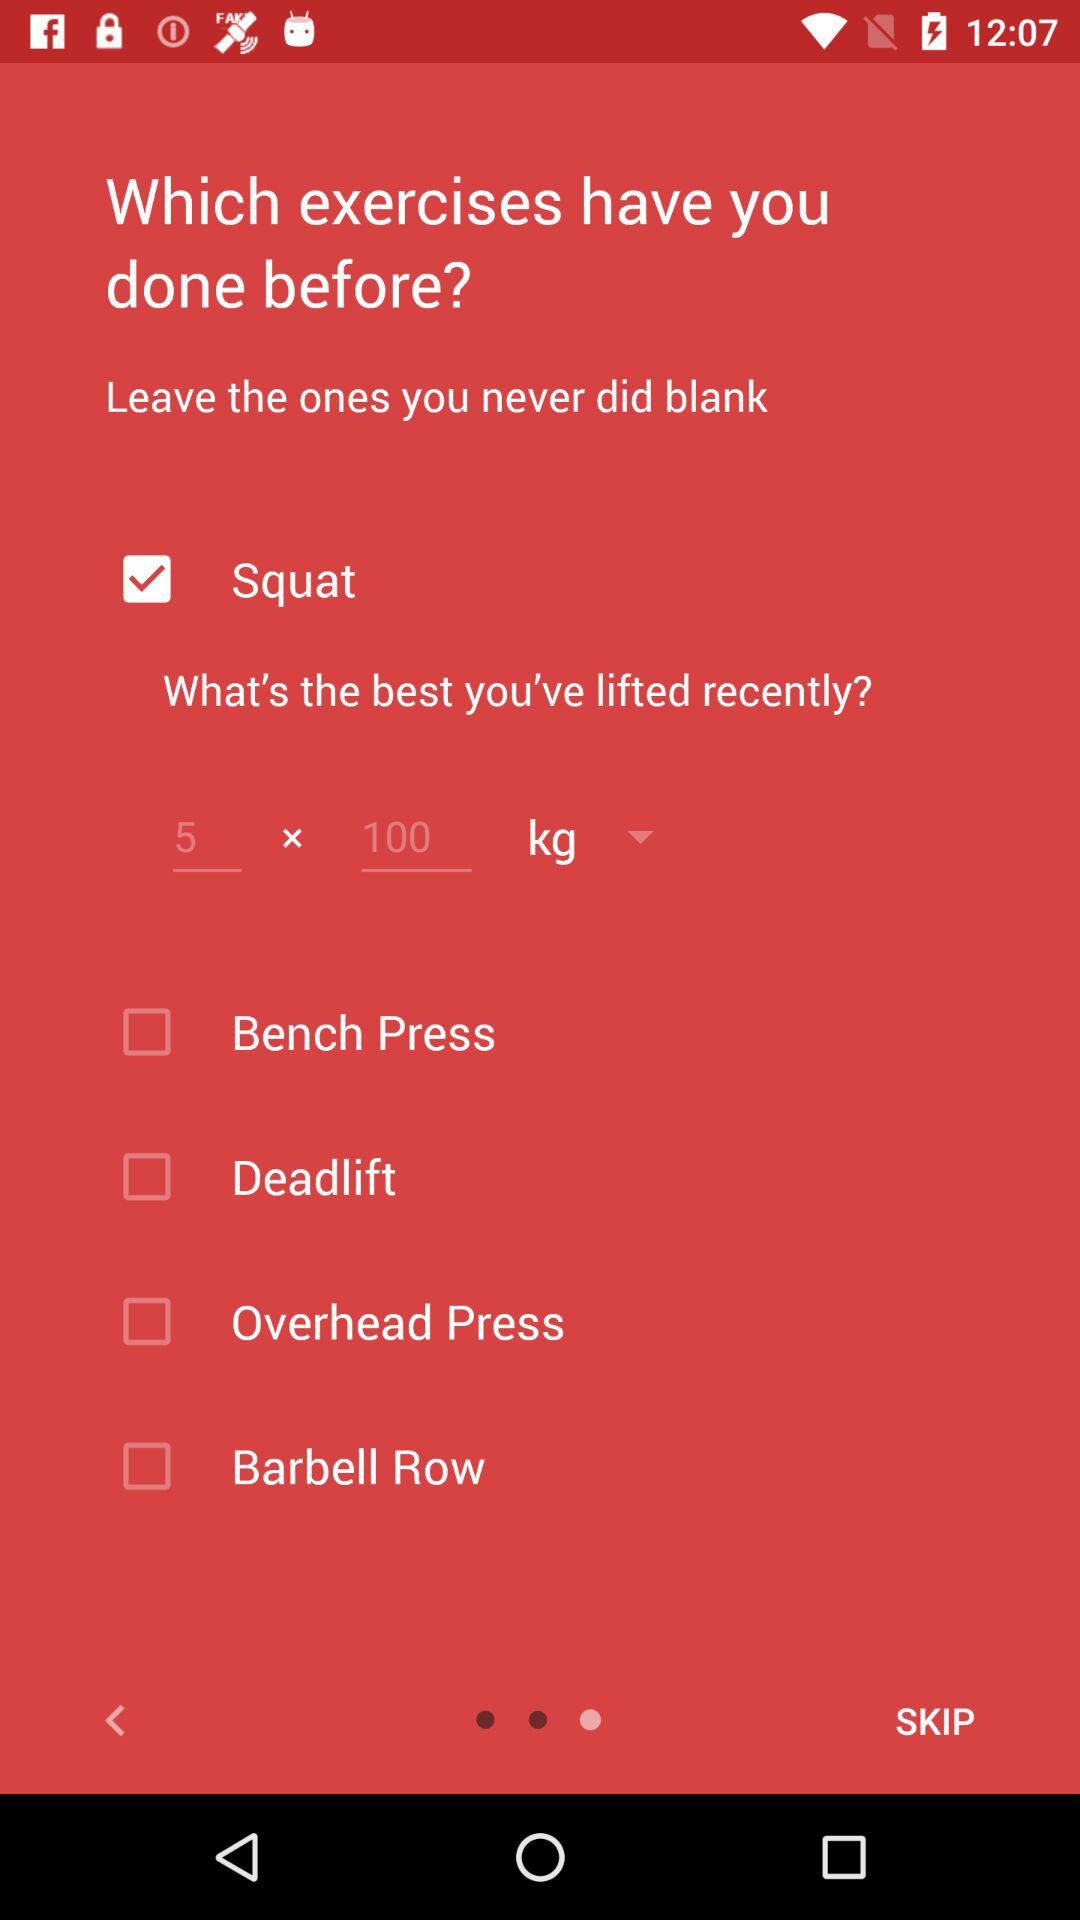What is the status of the "Squat"? The status of the "Squat" is "on". 